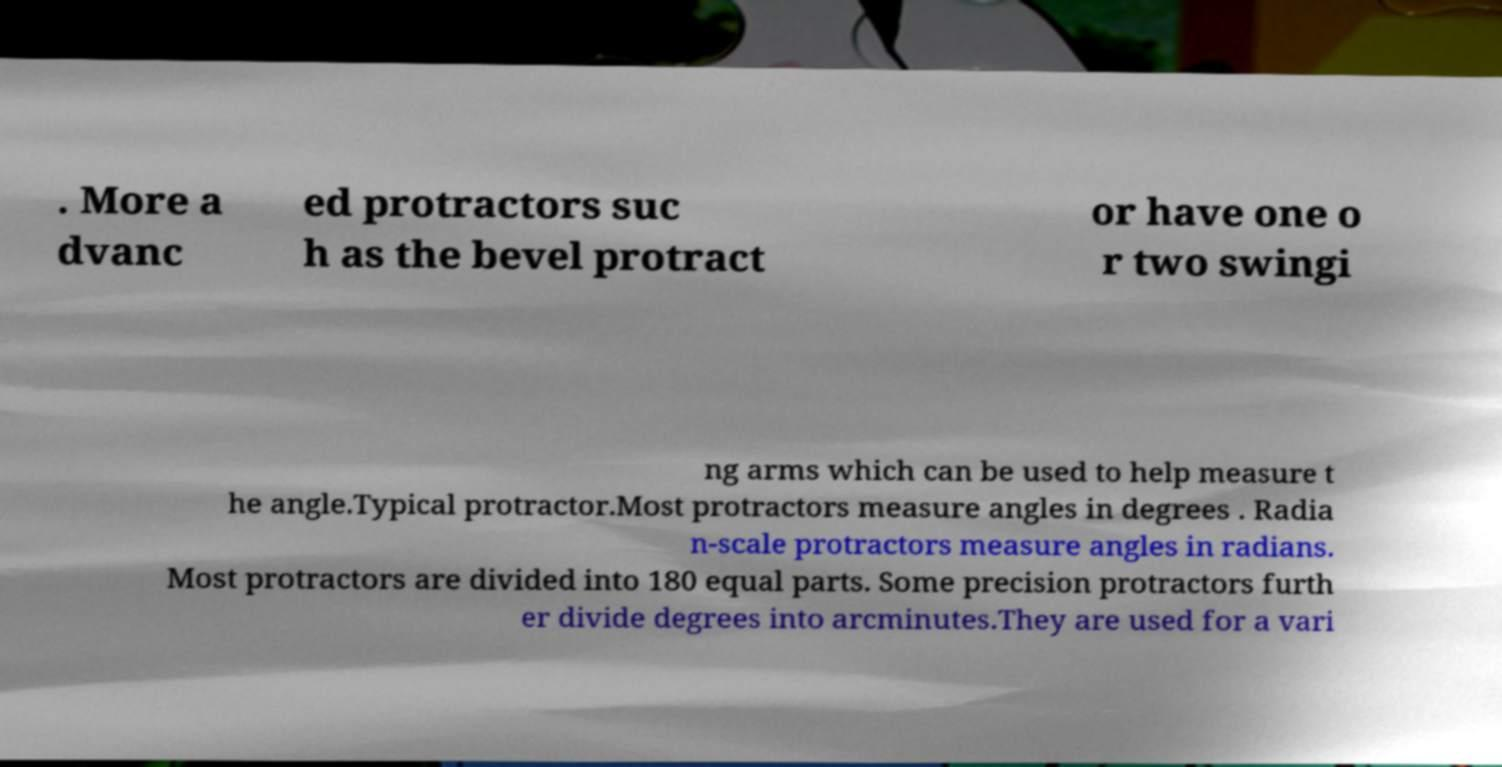Please identify and transcribe the text found in this image. . More a dvanc ed protractors suc h as the bevel protract or have one o r two swingi ng arms which can be used to help measure t he angle.Typical protractor.Most protractors measure angles in degrees . Radia n-scale protractors measure angles in radians. Most protractors are divided into 180 equal parts. Some precision protractors furth er divide degrees into arcminutes.They are used for a vari 